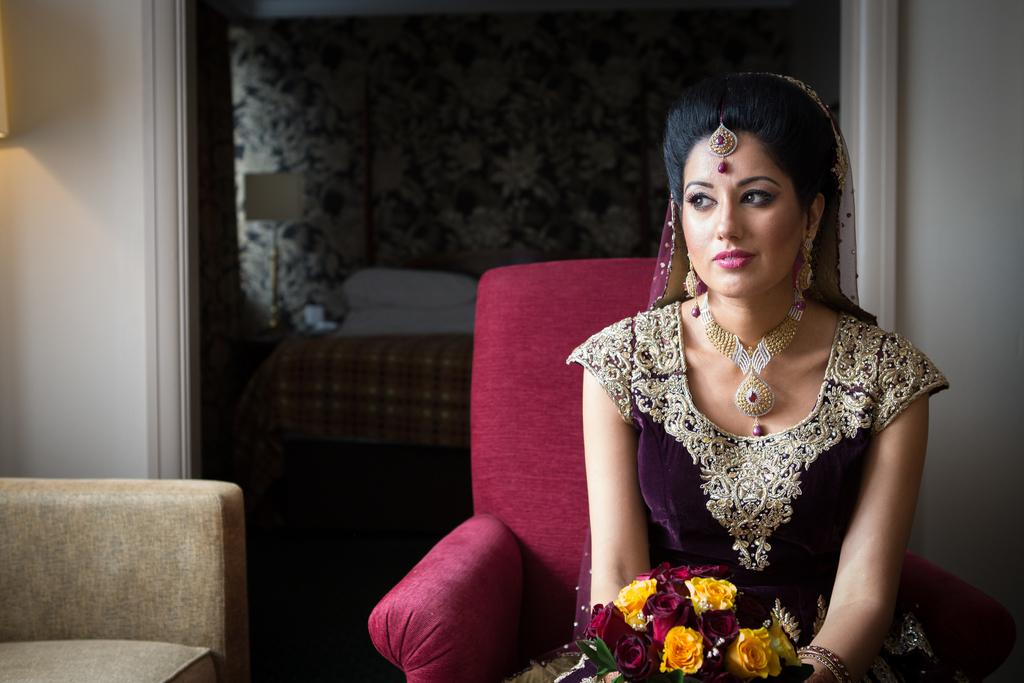Who is the main subject in the image? There is a woman in the image. What is the woman wearing? The woman is in bridal attire. What is the woman sitting on? The woman is sitting on a red color chair. What can be seen in the background of the image? There is a bedroom, a wall, and a lamp in the background of the image. What type of profit is the woman discussing with her lawyer in the image? There is no lawyer or discussion about profit in the image; it features a woman in bridal attire sitting on a red chair. Can you tell me how many holes are visible in the wall behind the woman? There is no mention of holes in the wall behind the woman; only a wall and a lamp are visible in the background. 